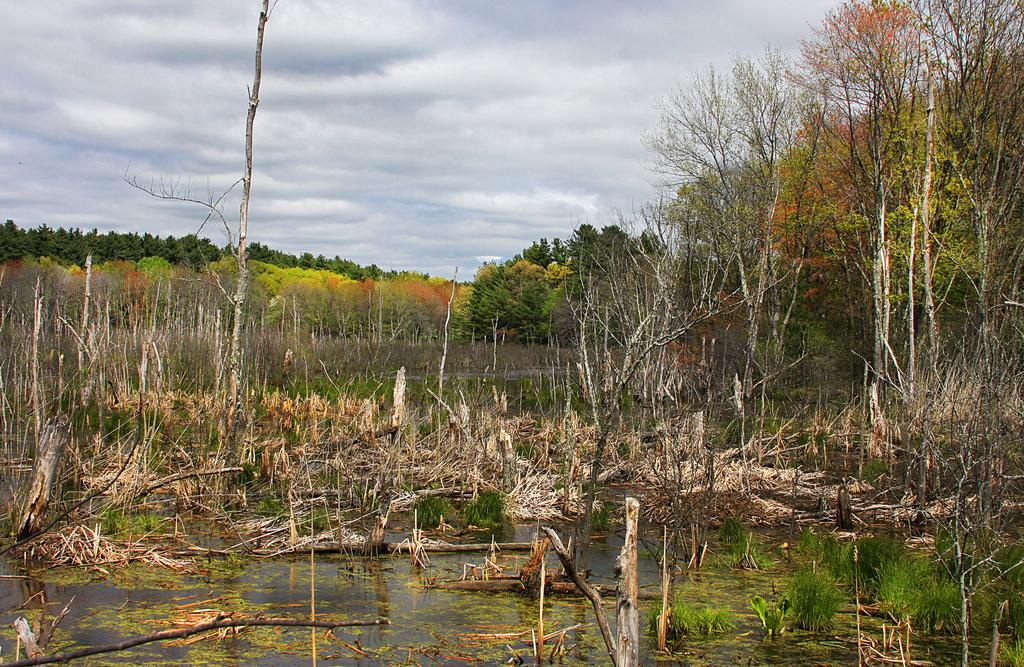What is the primary element visible in the image? There is water in the image. What objects are present in the water? There are wooden sticks in the image. What type of vegetation can be seen in the image? There are small plants and trees in the image. How would you describe the sky in the background? The sky in the background is cloudy. What type of dress is the water wearing in the image? The water is not wearing a dress, as it is a natural element and not a person or animate object. 